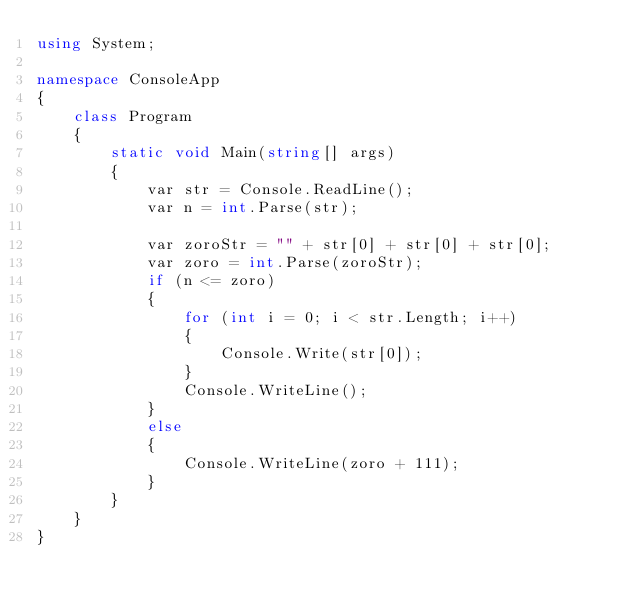Convert code to text. <code><loc_0><loc_0><loc_500><loc_500><_C#_>using System;

namespace ConsoleApp
{
    class Program
    {
        static void Main(string[] args)
        {
            var str = Console.ReadLine();
            var n = int.Parse(str);

            var zoroStr = "" + str[0] + str[0] + str[0];
            var zoro = int.Parse(zoroStr);
            if (n <= zoro)
            {
                for (int i = 0; i < str.Length; i++)
                {
                    Console.Write(str[0]);
                }
                Console.WriteLine();
            }
            else
            {
                Console.WriteLine(zoro + 111);
            }
        }
    }
}
</code> 